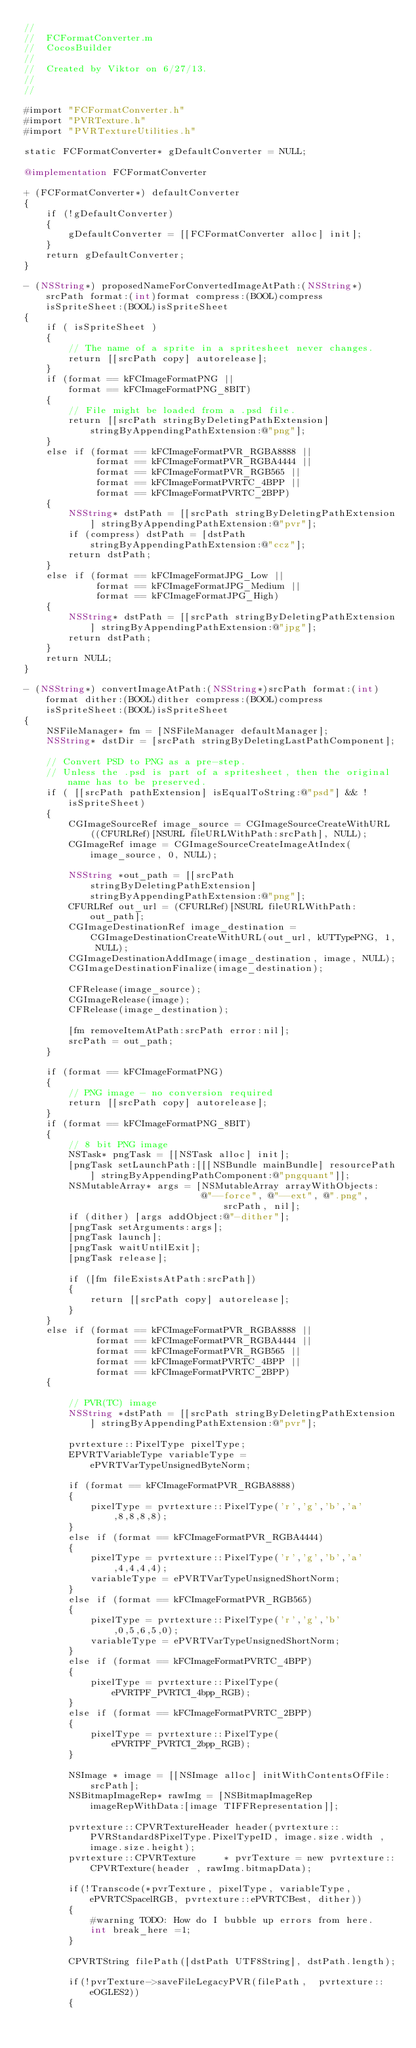<code> <loc_0><loc_0><loc_500><loc_500><_ObjectiveC_>//
//  FCFormatConverter.m
//  CocosBuilder
//
//  Created by Viktor on 6/27/13.
//
//

#import "FCFormatConverter.h"
#import "PVRTexture.h"
#import "PVRTextureUtilities.h"

static FCFormatConverter* gDefaultConverter = NULL;

@implementation FCFormatConverter

+ (FCFormatConverter*) defaultConverter
{
    if (!gDefaultConverter)
    {
        gDefaultConverter = [[FCFormatConverter alloc] init];
    }
    return gDefaultConverter;
}

- (NSString*) proposedNameForConvertedImageAtPath:(NSString*)srcPath format:(int)format compress:(BOOL)compress isSpriteSheet:(BOOL)isSpriteSheet
{
    if ( isSpriteSheet )
		{
		    // The name of a sprite in a spritesheet never changes.
		    return [[srcPath copy] autorelease];
		}
    if (format == kFCImageFormatPNG ||
        format == kFCImageFormatPNG_8BIT)
    {
        // File might be loaded from a .psd file.
        return [[srcPath stringByDeletingPathExtension] stringByAppendingPathExtension:@"png"];
    }
    else if (format == kFCImageFormatPVR_RGBA8888 ||
             format == kFCImageFormatPVR_RGBA4444 ||
             format == kFCImageFormatPVR_RGB565 ||
             format == kFCImageFormatPVRTC_4BPP ||
             format == kFCImageFormatPVRTC_2BPP)
    {
        NSString* dstPath = [[srcPath stringByDeletingPathExtension] stringByAppendingPathExtension:@"pvr"];
        if (compress) dstPath = [dstPath stringByAppendingPathExtension:@"ccz"];
        return dstPath;
    }
    else if (format == kFCImageFormatJPG_Low ||
             format == kFCImageFormatJPG_Medium ||
             format == kFCImageFormatJPG_High)
    {
        NSString* dstPath = [[srcPath stringByDeletingPathExtension] stringByAppendingPathExtension:@"jpg"];
        return dstPath;
    }
    return NULL;
}

- (NSString*) convertImageAtPath:(NSString*)srcPath format:(int)format dither:(BOOL)dither compress:(BOOL)compress isSpriteSheet:(BOOL)isSpriteSheet
{
    NSFileManager* fm = [NSFileManager defaultManager];
    NSString* dstDir = [srcPath stringByDeletingLastPathComponent];
    
		// Convert PSD to PNG as a pre-step.
		// Unless the .psd is part of a spritesheet, then the original name has to be preserved.
		if ( [[srcPath pathExtension] isEqualToString:@"psd"] && !isSpriteSheet)
		{
				CGImageSourceRef image_source = CGImageSourceCreateWithURL((CFURLRef)[NSURL fileURLWithPath:srcPath], NULL);
				CGImageRef image = CGImageSourceCreateImageAtIndex(image_source, 0, NULL);
				
				NSString *out_path = [[srcPath stringByDeletingPathExtension] stringByAppendingPathExtension:@"png"];
				CFURLRef out_url = (CFURLRef)[NSURL fileURLWithPath:out_path];
				CGImageDestinationRef image_destination = CGImageDestinationCreateWithURL(out_url, kUTTypePNG, 1, NULL);
				CGImageDestinationAddImage(image_destination, image, NULL);
				CGImageDestinationFinalize(image_destination);
				
				CFRelease(image_source);
				CGImageRelease(image);
				CFRelease(image_destination);
				
				[fm removeItemAtPath:srcPath error:nil];
				srcPath = out_path;
		}
		
    if (format == kFCImageFormatPNG)
    {
        // PNG image - no conversion required
        return [[srcPath copy] autorelease];
    }
    if (format == kFCImageFormatPNG_8BIT)
    {
        // 8 bit PNG image
        NSTask* pngTask = [[NSTask alloc] init];
        [pngTask setLaunchPath:[[[NSBundle mainBundle] resourcePath] stringByAppendingPathComponent:@"pngquant"]];
        NSMutableArray* args = [NSMutableArray arrayWithObjects:
                                @"--force", @"--ext", @".png", srcPath, nil];
        if (dither) [args addObject:@"-dither"];
        [pngTask setArguments:args];
        [pngTask launch];
        [pngTask waitUntilExit];
        [pngTask release];
        
        if ([fm fileExistsAtPath:srcPath])
        {
            return [[srcPath copy] autorelease];
        }
    }
    else if (format == kFCImageFormatPVR_RGBA8888 ||
             format == kFCImageFormatPVR_RGBA4444 ||
             format == kFCImageFormatPVR_RGB565 ||
             format == kFCImageFormatPVRTC_4BPP ||
             format == kFCImageFormatPVRTC_2BPP)
    {
        
        // PVR(TC) image
        NSString *dstPath = [[srcPath stringByDeletingPathExtension] stringByAppendingPathExtension:@"pvr"];
        
        pvrtexture::PixelType pixelType;
        EPVRTVariableType variableType = ePVRTVarTypeUnsignedByteNorm;
        
        if (format == kFCImageFormatPVR_RGBA8888)
        {
            pixelType = pvrtexture::PixelType('r','g','b','a',8,8,8,8);
        }
        else if (format == kFCImageFormatPVR_RGBA4444)
        {
            pixelType = pvrtexture::PixelType('r','g','b','a',4,4,4,4);
            variableType = ePVRTVarTypeUnsignedShortNorm;
        }
        else if (format == kFCImageFormatPVR_RGB565)
        {
            pixelType = pvrtexture::PixelType('r','g','b',0,5,6,5,0);
            variableType = ePVRTVarTypeUnsignedShortNorm;
        }
        else if (format == kFCImageFormatPVRTC_4BPP)
        {
            pixelType = pvrtexture::PixelType(ePVRTPF_PVRTCI_4bpp_RGB);
        }
        else if (format == kFCImageFormatPVRTC_2BPP)
        {
            pixelType = pvrtexture::PixelType(ePVRTPF_PVRTCI_2bpp_RGB);
        }

        NSImage * image = [[NSImage alloc] initWithContentsOfFile:srcPath];
        NSBitmapImageRep* rawImg = [NSBitmapImageRep imageRepWithData:[image TIFFRepresentation]];
        
        pvrtexture::CPVRTextureHeader header(pvrtexture::PVRStandard8PixelType.PixelTypeID, image.size.width , image.size.height);
        pvrtexture::CPVRTexture     * pvrTexture = new pvrtexture::CPVRTexture(header , rawImg.bitmapData);
        
        if(!Transcode(*pvrTexture, pixelType, variableType, ePVRTCSpacelRGB, pvrtexture::ePVRTCBest, dither))
        {
            #warning TODO: How do I bubble up errors from here.
            int break_here =1;
        }
        
        CPVRTString filePath([dstPath UTF8String], dstPath.length);
        
        if(!pvrTexture->saveFileLegacyPVR(filePath,  pvrtexture::eOGLES2))
        {</code> 